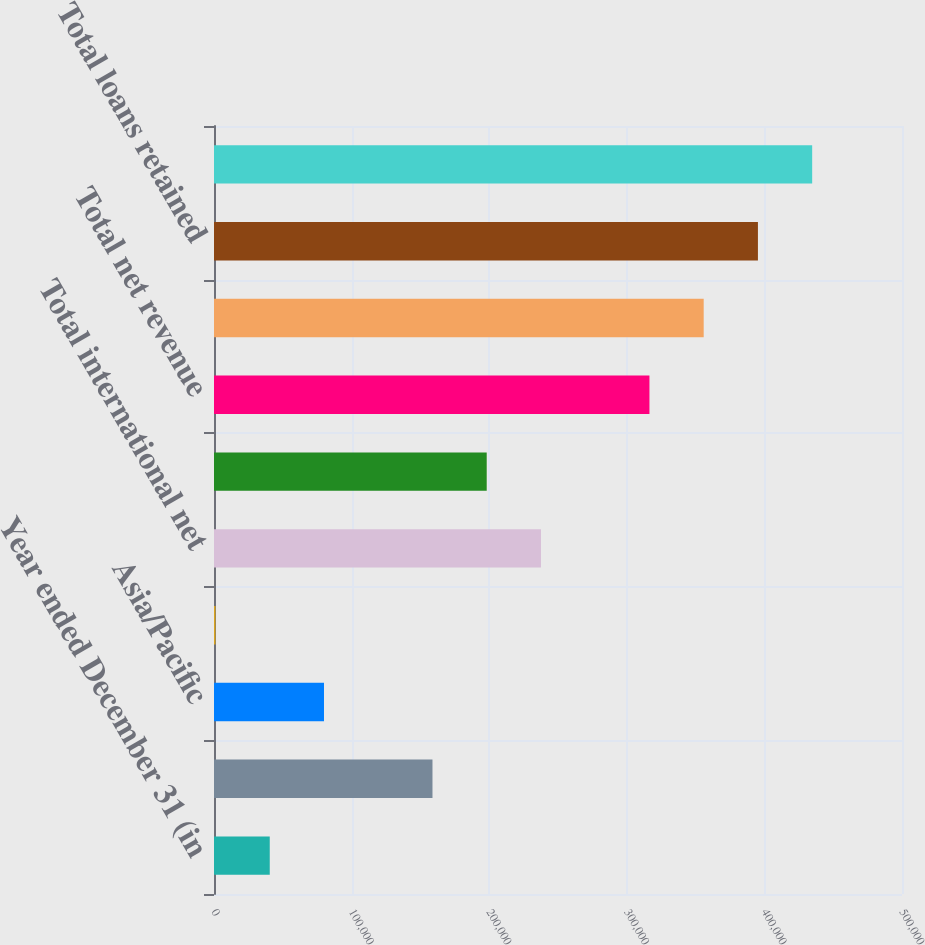Convert chart to OTSL. <chart><loc_0><loc_0><loc_500><loc_500><bar_chart><fcel>Year ended December 31 (in<fcel>Europe/Middle East/Africa<fcel>Asia/Pacific<fcel>Latin America/Caribbean<fcel>Total international net<fcel>North America<fcel>Total net revenue<fcel>Total international loans<fcel>Total loans retained<fcel>Total international<nl><fcel>40516.1<fcel>158776<fcel>79936.2<fcel>1096<fcel>237617<fcel>198196<fcel>316457<fcel>355877<fcel>395297<fcel>434717<nl></chart> 